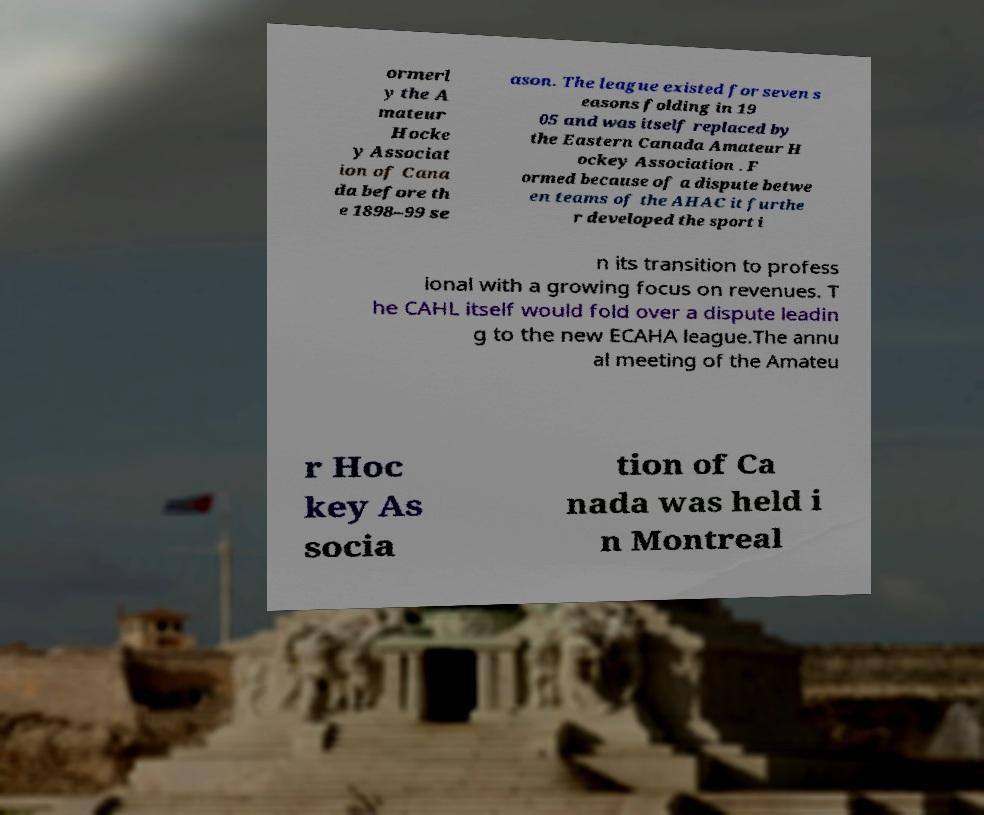There's text embedded in this image that I need extracted. Can you transcribe it verbatim? ormerl y the A mateur Hocke y Associat ion of Cana da before th e 1898–99 se ason. The league existed for seven s easons folding in 19 05 and was itself replaced by the Eastern Canada Amateur H ockey Association . F ormed because of a dispute betwe en teams of the AHAC it furthe r developed the sport i n its transition to profess ional with a growing focus on revenues. T he CAHL itself would fold over a dispute leadin g to the new ECAHA league.The annu al meeting of the Amateu r Hoc key As socia tion of Ca nada was held i n Montreal 